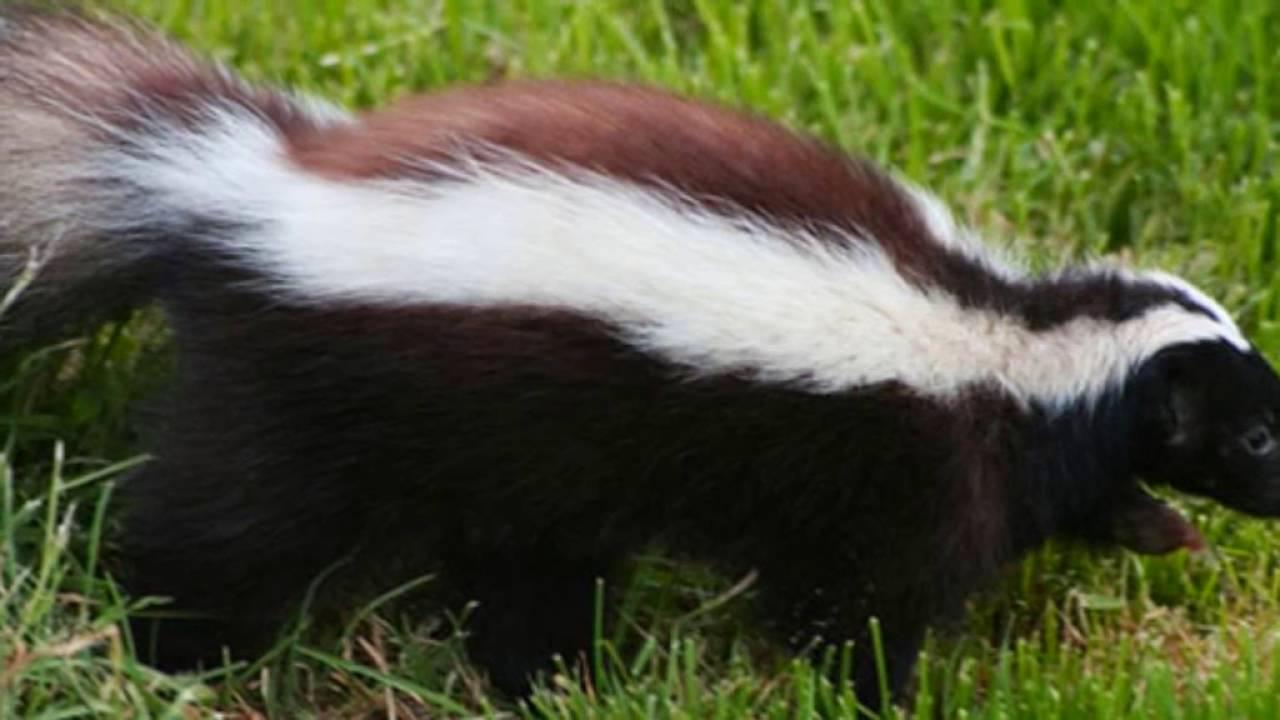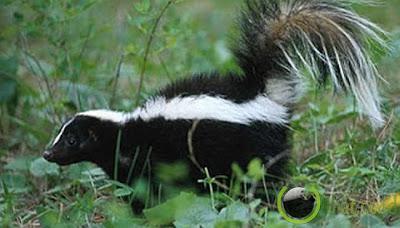The first image is the image on the left, the second image is the image on the right. Considering the images on both sides, is "There are three skunks in total." valid? Answer yes or no. No. The first image is the image on the left, the second image is the image on the right. Assess this claim about the two images: "There are three skunks.". Correct or not? Answer yes or no. No. 